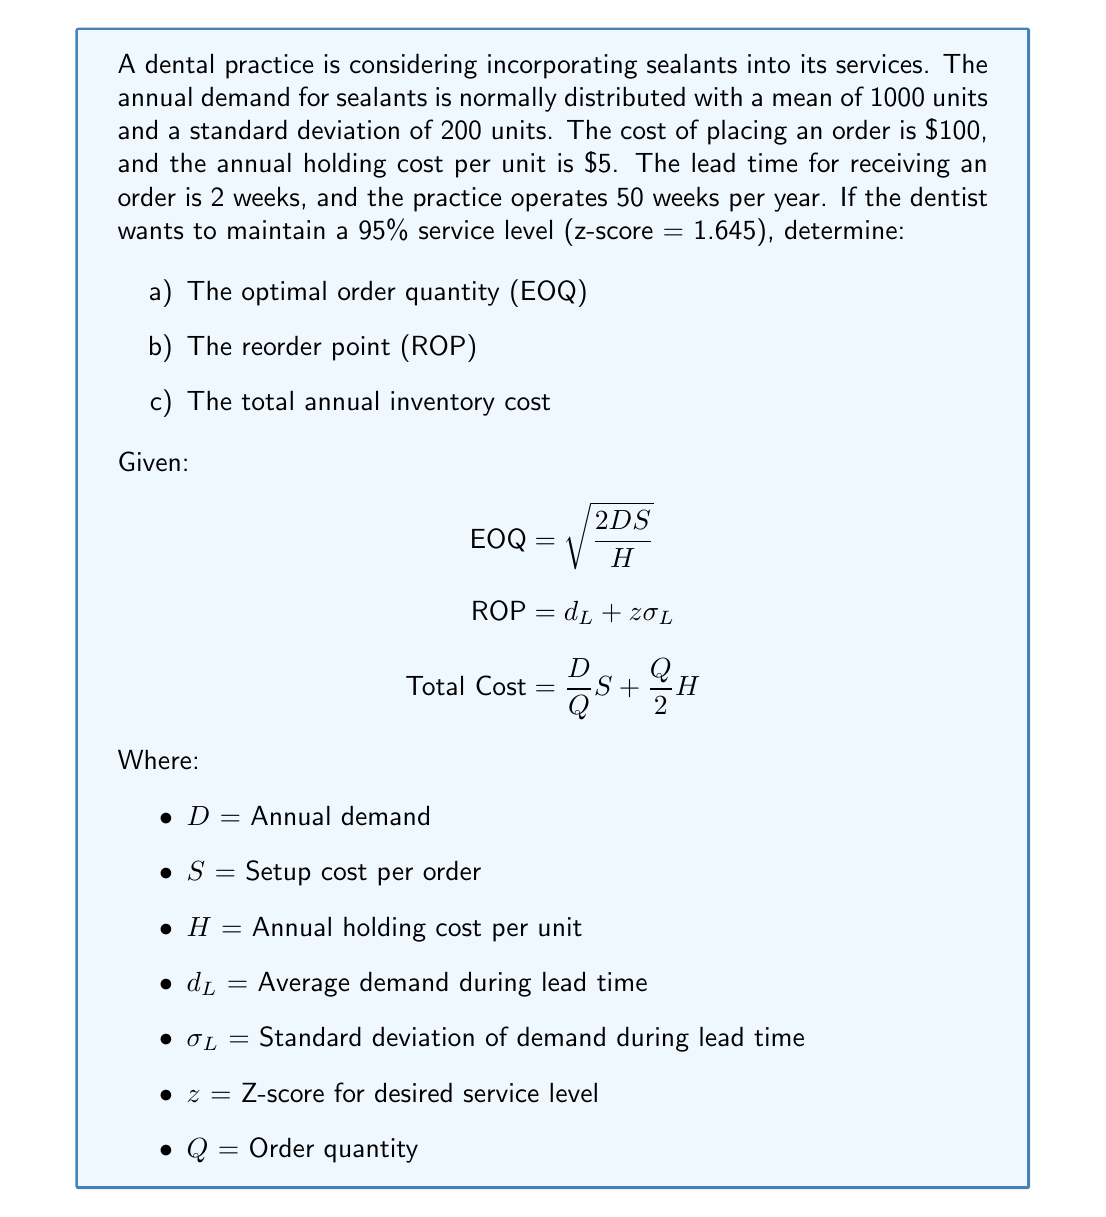What is the answer to this math problem? Let's solve this problem step by step:

1. Calculate the Economic Order Quantity (EOQ):
   $$\text{EOQ} = \sqrt{\frac{2DS}{H}} = \sqrt{\frac{2 \times 1000 \times 100}{5}} = \sqrt{40,000} \approx 200 \text{ units}$$

2. Calculate the Reorder Point (ROP):
   a) First, calculate the average demand during lead time (d_L):
      $$d_L = \frac{1000 \text{ units}}{50 \text{ weeks}} \times 2 \text{ weeks} = 40 \text{ units}$$
   
   b) Calculate the standard deviation of demand during lead time (σ_L):
      $$\sigma_L = 200 \times \sqrt{\frac{2}{50}} \approx 40 \text{ units}$$
   
   c) Now calculate the ROP:
      $$\text{ROP} = d_L + z\sigma_L = 40 + 1.645 \times 40 \approx 106 \text{ units}$$

3. Calculate the Total Annual Inventory Cost:
   Using the EOQ as the order quantity (Q), we get:
   $$\text{Total Cost} = \frac{D}{Q}S + \frac{Q}{2}H = \frac{1000}{200} \times 100 + \frac{200}{2} \times 5 = 500 + 500 = 1000$$

Therefore, the total annual inventory cost is $1000.
Answer: a) EOQ ≈ 200 units
b) ROP ≈ 106 units
c) Total annual inventory cost = $1000 